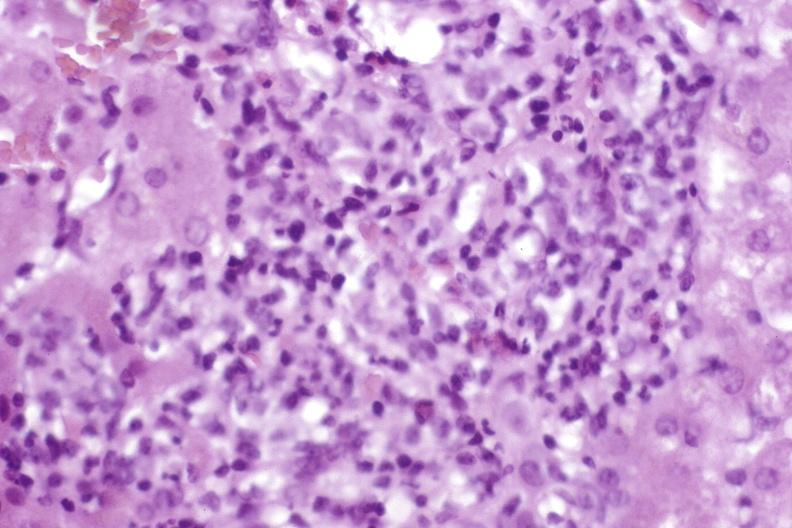what is present?
Answer the question using a single word or phrase. Liver 